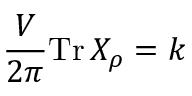<formula> <loc_0><loc_0><loc_500><loc_500>\frac { V } { 2 \pi } T r \, X _ { \rho } = k</formula> 